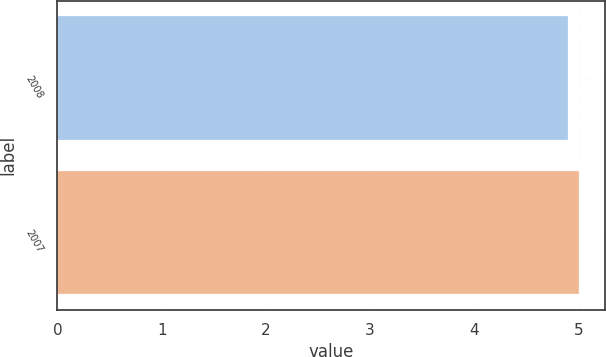Convert chart to OTSL. <chart><loc_0><loc_0><loc_500><loc_500><bar_chart><fcel>2008<fcel>2007<nl><fcel>4.9<fcel>5<nl></chart> 